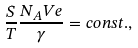<formula> <loc_0><loc_0><loc_500><loc_500>\frac { S } { T } \frac { N _ { A } V e } { \gamma } = c o n s t . ,</formula> 